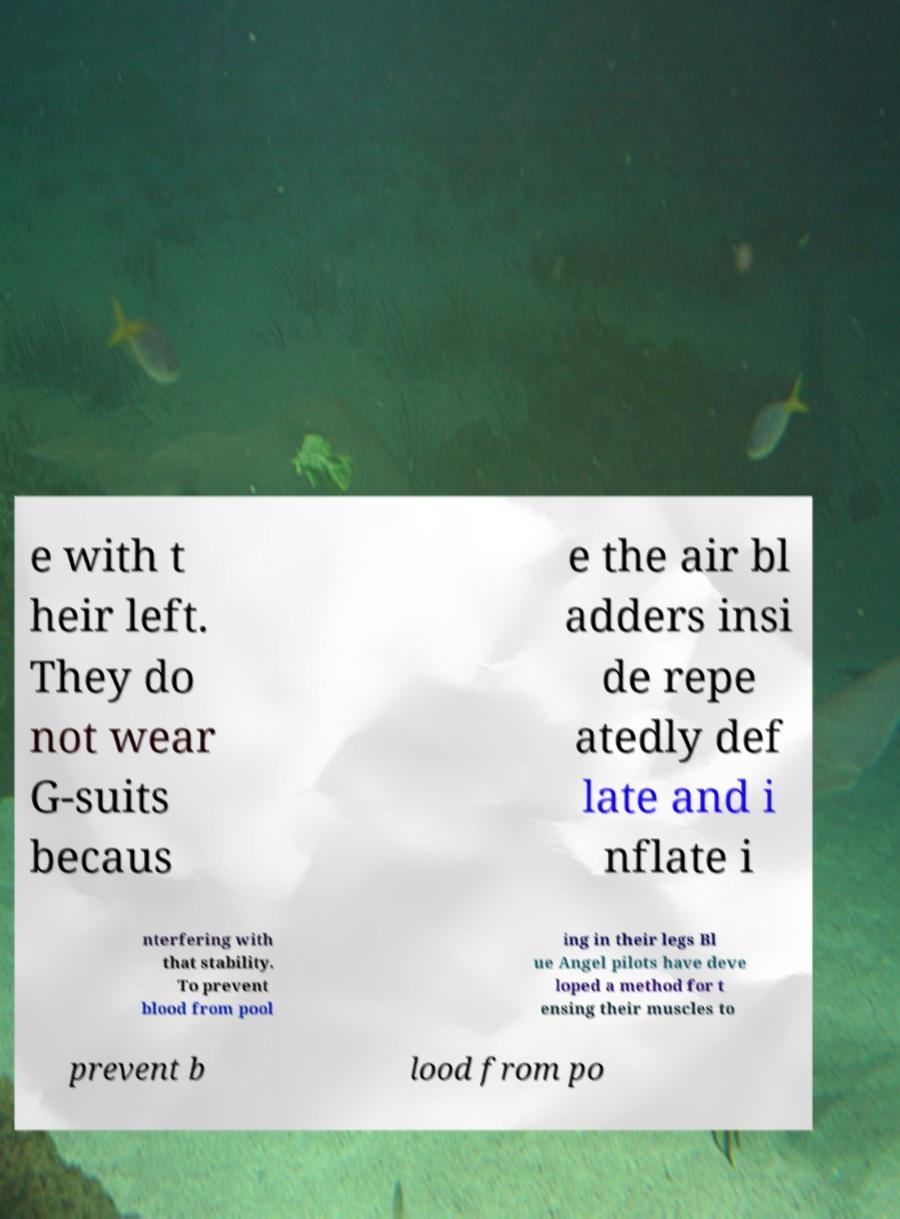What messages or text are displayed in this image? I need them in a readable, typed format. e with t heir left. They do not wear G-suits becaus e the air bl adders insi de repe atedly def late and i nflate i nterfering with that stability. To prevent blood from pool ing in their legs Bl ue Angel pilots have deve loped a method for t ensing their muscles to prevent b lood from po 